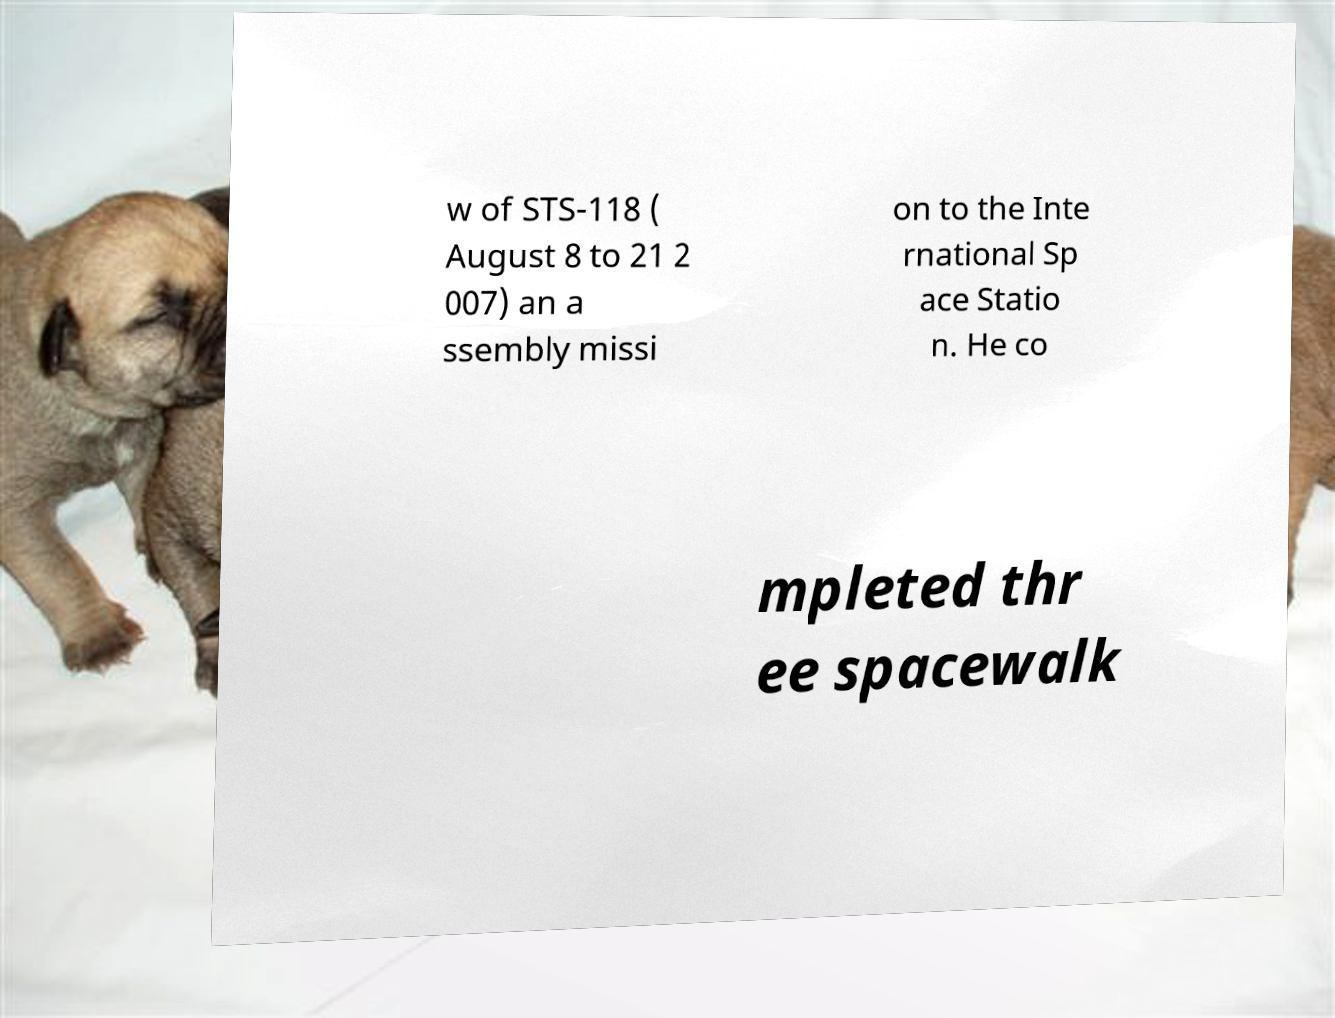I need the written content from this picture converted into text. Can you do that? w of STS-118 ( August 8 to 21 2 007) an a ssembly missi on to the Inte rnational Sp ace Statio n. He co mpleted thr ee spacewalk 